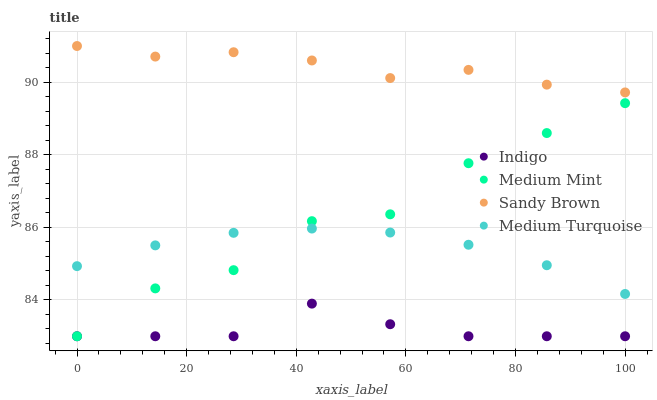Does Indigo have the minimum area under the curve?
Answer yes or no. Yes. Does Sandy Brown have the maximum area under the curve?
Answer yes or no. Yes. Does Sandy Brown have the minimum area under the curve?
Answer yes or no. No. Does Indigo have the maximum area under the curve?
Answer yes or no. No. Is Medium Turquoise the smoothest?
Answer yes or no. Yes. Is Medium Mint the roughest?
Answer yes or no. Yes. Is Sandy Brown the smoothest?
Answer yes or no. No. Is Sandy Brown the roughest?
Answer yes or no. No. Does Medium Mint have the lowest value?
Answer yes or no. Yes. Does Sandy Brown have the lowest value?
Answer yes or no. No. Does Sandy Brown have the highest value?
Answer yes or no. Yes. Does Indigo have the highest value?
Answer yes or no. No. Is Indigo less than Sandy Brown?
Answer yes or no. Yes. Is Sandy Brown greater than Indigo?
Answer yes or no. Yes. Does Indigo intersect Medium Mint?
Answer yes or no. Yes. Is Indigo less than Medium Mint?
Answer yes or no. No. Is Indigo greater than Medium Mint?
Answer yes or no. No. Does Indigo intersect Sandy Brown?
Answer yes or no. No. 